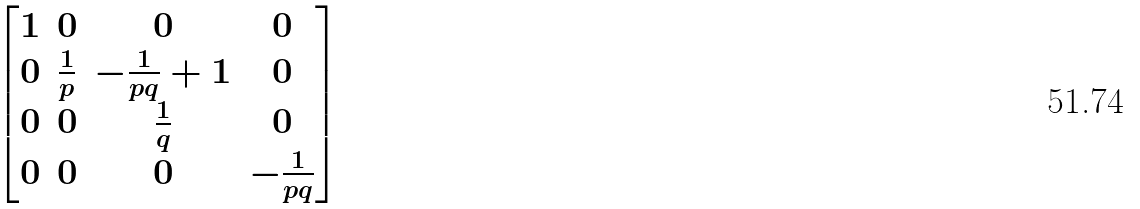<formula> <loc_0><loc_0><loc_500><loc_500>\begin{bmatrix} 1 & 0 & 0 & 0 \\ 0 & \frac { 1 } { p } & - \frac { 1 } { p q } + 1 & 0 \\ 0 & 0 & \frac { 1 } { q } & 0 \\ 0 & 0 & 0 & - \frac { 1 } { p q } \end{bmatrix}</formula> 